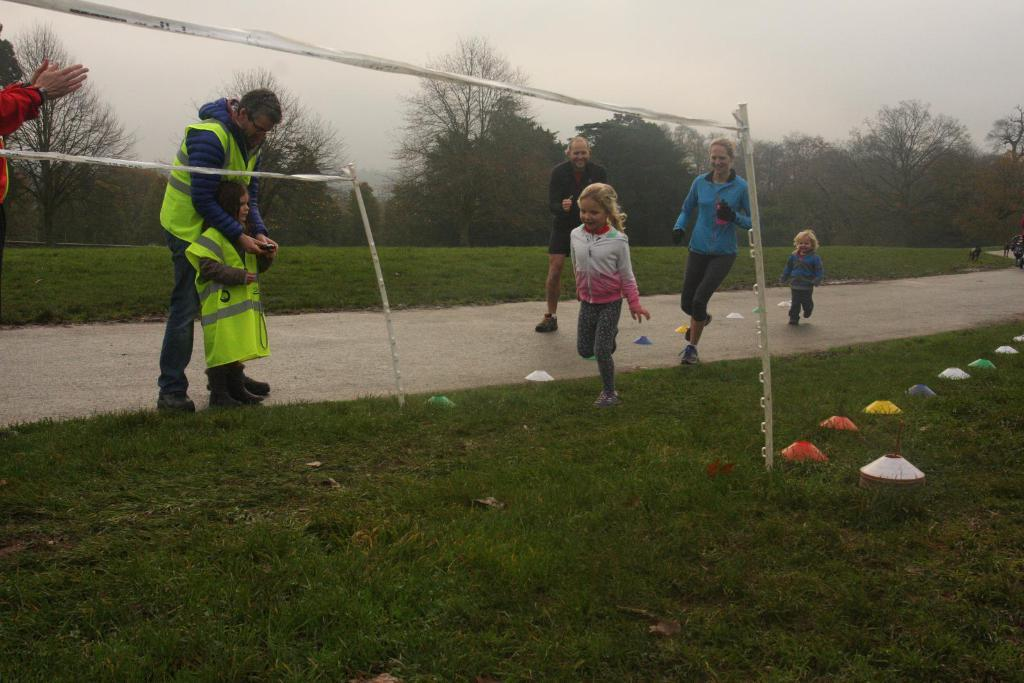What are the people in the image doing? There are people running and standing in the image. What is the ground surface like in the image? There is grass on the ground in the image. What type of vegetation is present in the image? There are trees in the image. What is the condition of the sky in the image? The sky is cloudy in the image. What type of flag is being waved by the girl in the image? There is no girl present in the image, and no flag is being waved. 